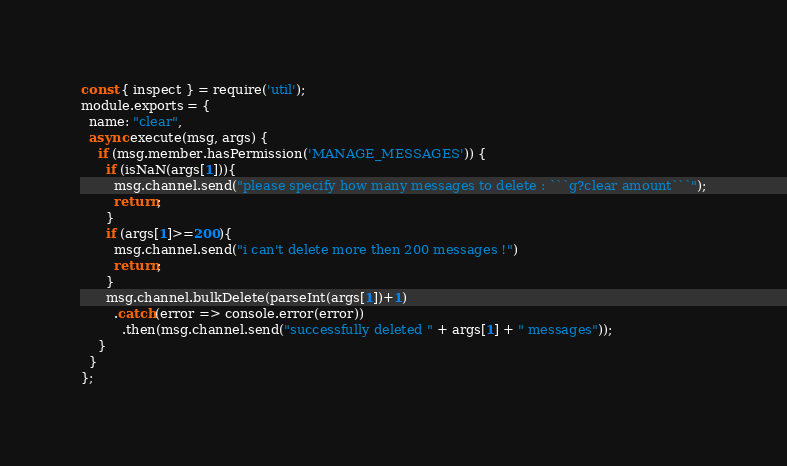Convert code to text. <code><loc_0><loc_0><loc_500><loc_500><_JavaScript_>const { inspect } = require('util');
module.exports = {
  name: "clear",
  async execute(msg, args) {
    if (msg.member.hasPermission('MANAGE_MESSAGES')) {
      if (isNaN(args[1])){
        msg.channel.send("please specify how many messages to delete : ```g?clear amount```");
        return;
      }
      if (args[1]>=200){
        msg.channel.send("i can't delete more then 200 messages !")
        return;
      }
      msg.channel.bulkDelete(parseInt(args[1])+1)
        .catch(error => console.error(error))
          .then(msg.channel.send("successfully deleted " + args[1] + " messages"));
    }
  }
};</code> 